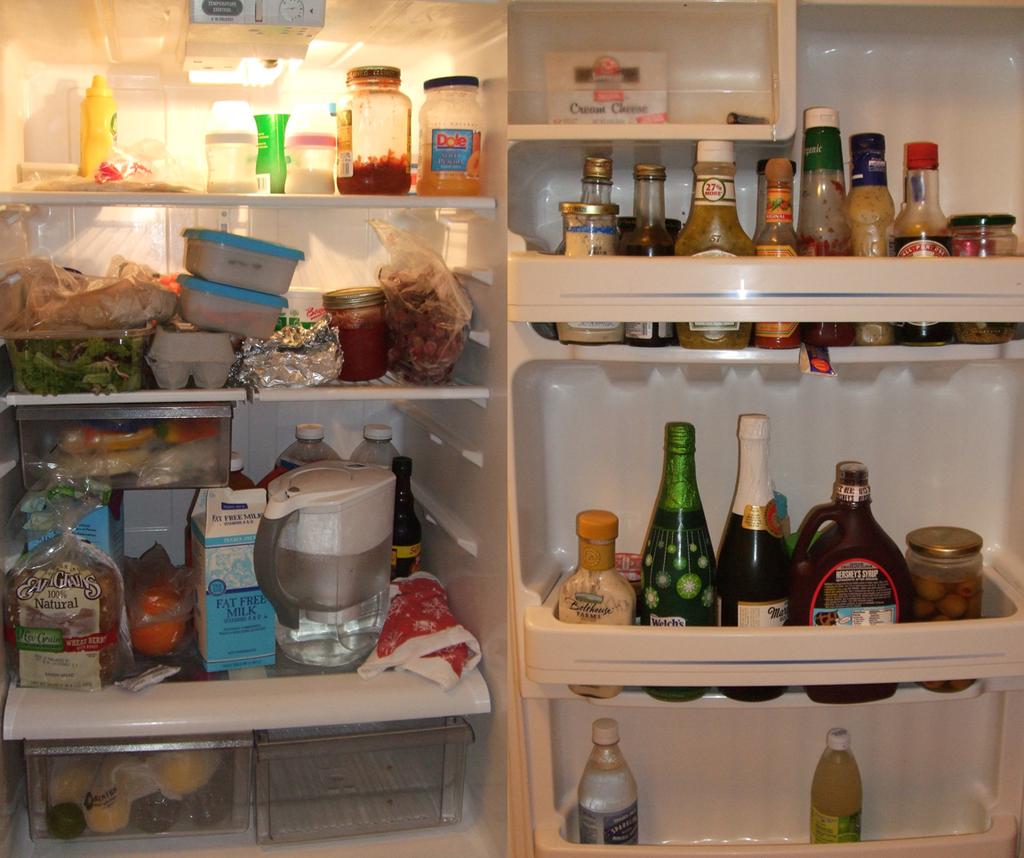What brand of chocolate syrup is in the door?
Offer a terse response. Hershey's. 